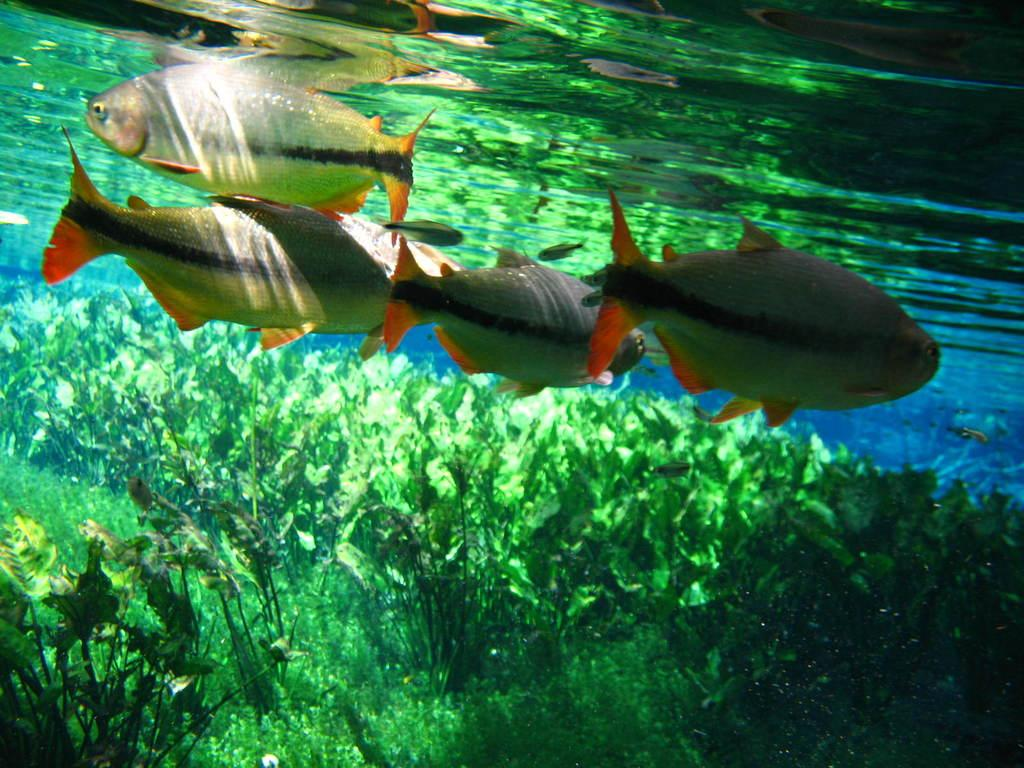What is happening in the water in the image? There are fishes swimming in the water. Are there any other elements present in the water besides the fishes? Yes, there are plants inside the water. What is the interest in the image? There is no reference to interest in the image. The image features fishes swimming in the water and plants inside the water. 